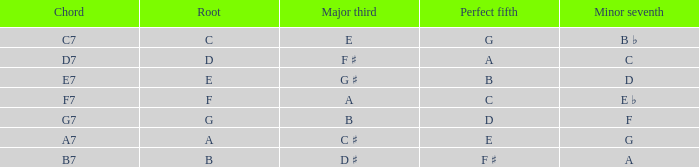What is the Chord with a Major that is third of e? C7. 